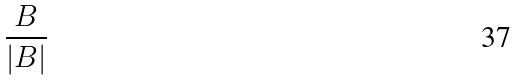<formula> <loc_0><loc_0><loc_500><loc_500>\frac { B } { | B | }</formula> 